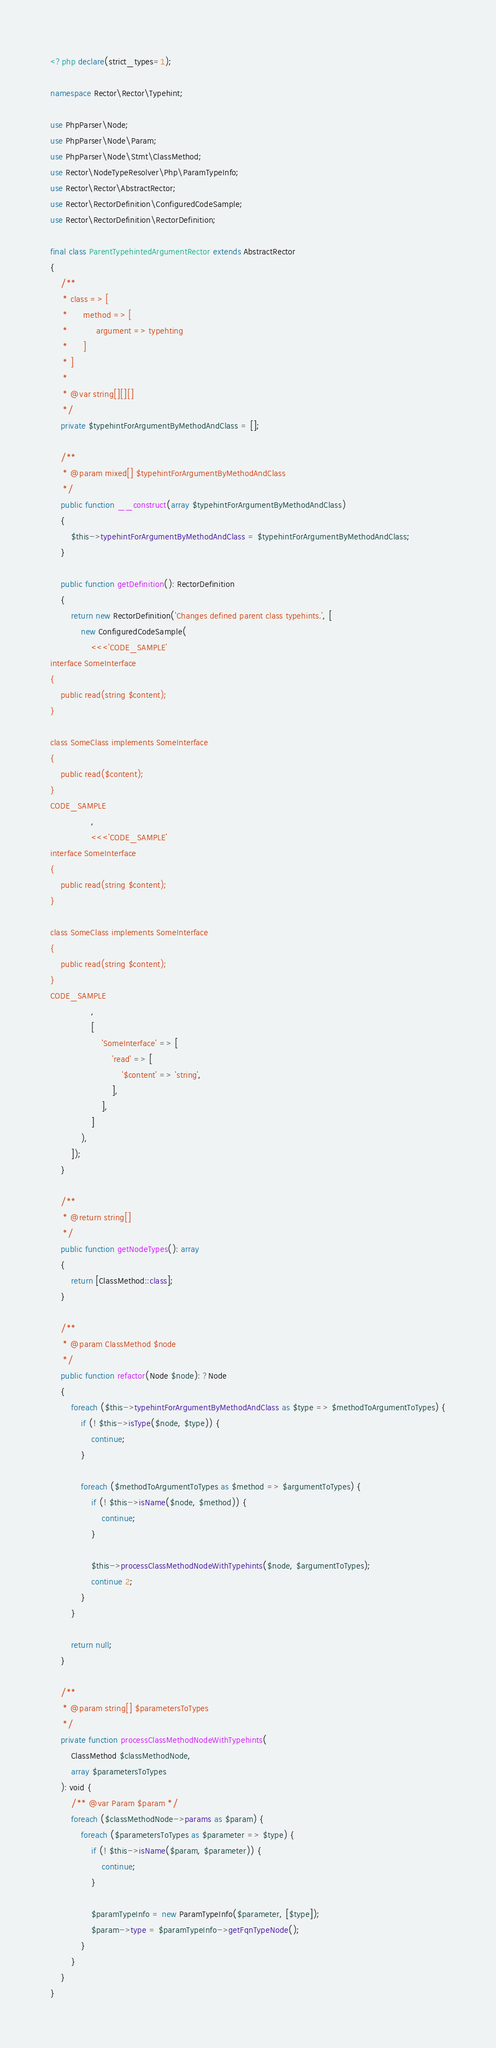Convert code to text. <code><loc_0><loc_0><loc_500><loc_500><_PHP_><?php declare(strict_types=1);

namespace Rector\Rector\Typehint;

use PhpParser\Node;
use PhpParser\Node\Param;
use PhpParser\Node\Stmt\ClassMethod;
use Rector\NodeTypeResolver\Php\ParamTypeInfo;
use Rector\Rector\AbstractRector;
use Rector\RectorDefinition\ConfiguredCodeSample;
use Rector\RectorDefinition\RectorDefinition;

final class ParentTypehintedArgumentRector extends AbstractRector
{
    /**
     * class => [
     *      method => [
     *           argument => typehting
     *      ]
     * ]
     *
     * @var string[][][]
     */
    private $typehintForArgumentByMethodAndClass = [];

    /**
     * @param mixed[] $typehintForArgumentByMethodAndClass
     */
    public function __construct(array $typehintForArgumentByMethodAndClass)
    {
        $this->typehintForArgumentByMethodAndClass = $typehintForArgumentByMethodAndClass;
    }

    public function getDefinition(): RectorDefinition
    {
        return new RectorDefinition('Changes defined parent class typehints.', [
            new ConfiguredCodeSample(
                <<<'CODE_SAMPLE'
interface SomeInterface
{
    public read(string $content);
}

class SomeClass implements SomeInterface
{
    public read($content);
}
CODE_SAMPLE
                ,
                <<<'CODE_SAMPLE'
interface SomeInterface
{
    public read(string $content);
}

class SomeClass implements SomeInterface
{
    public read(string $content);
}
CODE_SAMPLE
                ,
                [
                    'SomeInterface' => [
                        'read' => [
                            '$content' => 'string',
                        ],
                    ],
                ]
            ),
        ]);
    }

    /**
     * @return string[]
     */
    public function getNodeTypes(): array
    {
        return [ClassMethod::class];
    }

    /**
     * @param ClassMethod $node
     */
    public function refactor(Node $node): ?Node
    {
        foreach ($this->typehintForArgumentByMethodAndClass as $type => $methodToArgumentToTypes) {
            if (! $this->isType($node, $type)) {
                continue;
            }

            foreach ($methodToArgumentToTypes as $method => $argumentToTypes) {
                if (! $this->isName($node, $method)) {
                    continue;
                }

                $this->processClassMethodNodeWithTypehints($node, $argumentToTypes);
                continue 2;
            }
        }

        return null;
    }

    /**
     * @param string[] $parametersToTypes
     */
    private function processClassMethodNodeWithTypehints(
        ClassMethod $classMethodNode,
        array $parametersToTypes
    ): void {
        /** @var Param $param */
        foreach ($classMethodNode->params as $param) {
            foreach ($parametersToTypes as $parameter => $type) {
                if (! $this->isName($param, $parameter)) {
                    continue;
                }

                $paramTypeInfo = new ParamTypeInfo($parameter, [$type]);
                $param->type = $paramTypeInfo->getFqnTypeNode();
            }
        }
    }
}
</code> 